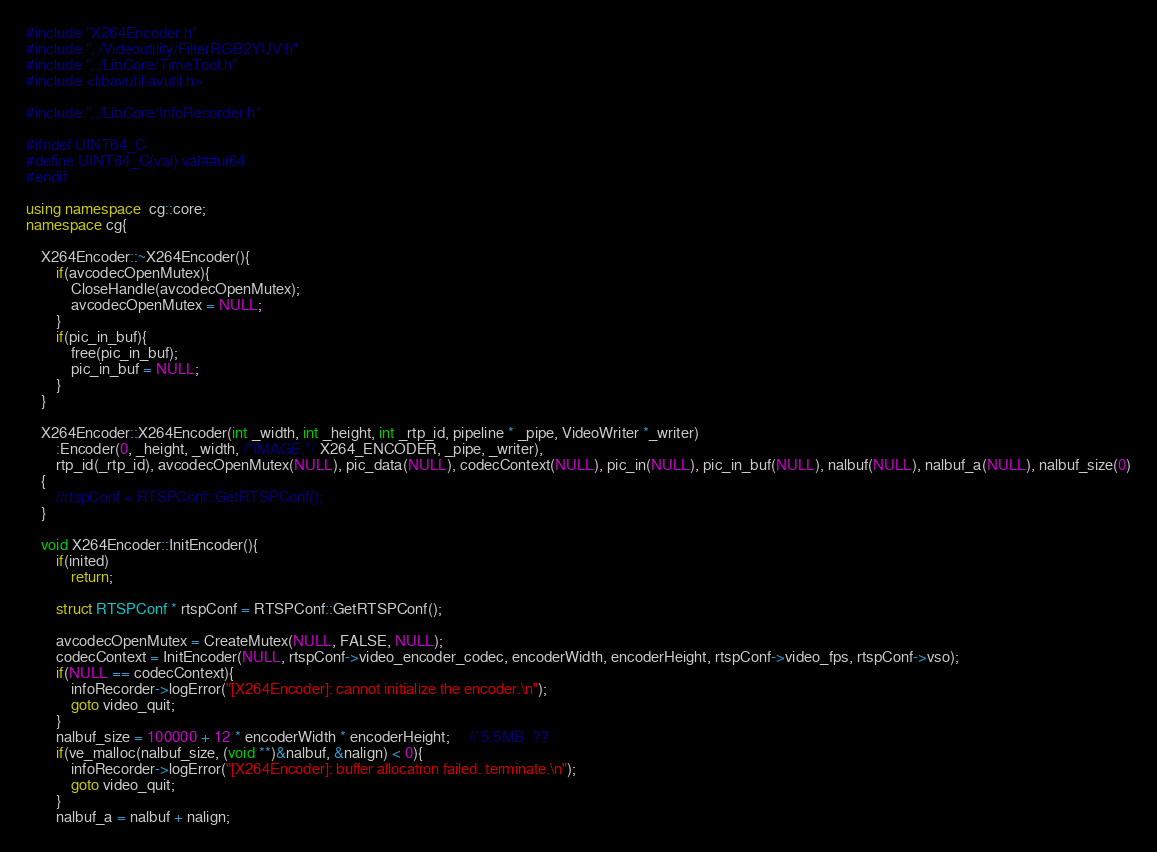Convert code to text. <code><loc_0><loc_0><loc_500><loc_500><_C++_>#include "X264Encoder.h"
#include "../Videoutility/FilterRGB2YUV.h"
#include "../LibCore/TimeTool.h"
#include <libavutil\avutil.h>

#include "../LibCore/InfoRecorder.h"

#ifndef UINT64_C
#define UINT64_C(val) val##ui64
#endif

using namespace  cg::core;
namespace cg{

	X264Encoder::~X264Encoder(){
		if(avcodecOpenMutex){
			CloseHandle(avcodecOpenMutex);
			avcodecOpenMutex = NULL;
		}
		if(pic_in_buf){
			free(pic_in_buf);
			pic_in_buf = NULL;
		}
	}

	X264Encoder::X264Encoder(int _width, int _height, int _rtp_id, pipeline * _pipe, VideoWriter *_writer)
		:Encoder(0, _height, _width, /*IMAGE,*/ X264_ENCODER, _pipe, _writer), 
		rtp_id(_rtp_id), avcodecOpenMutex(NULL), pic_data(NULL), codecContext(NULL), pic_in(NULL), pic_in_buf(NULL), nalbuf(NULL), nalbuf_a(NULL), nalbuf_size(0)
	{
		//rtspConf = RTSPConf::GetRTSPConf();
	}

	void X264Encoder::InitEncoder(){
		if(inited)
			return;

		struct RTSPConf * rtspConf = RTSPConf::GetRTSPConf();

		avcodecOpenMutex = CreateMutex(NULL, FALSE, NULL);
		codecContext = InitEncoder(NULL, rtspConf->video_encoder_codec, encoderWidth, encoderHeight, rtspConf->video_fps, rtspConf->vso);
		if(NULL == codecContext){
			infoRecorder->logError("[X264Encoder]: cannot initialize the encoder.\n");
			goto video_quit;
		}
		nalbuf_size = 100000 + 12 * encoderWidth * encoderHeight;     // 5.5MB  ??
		if(ve_malloc(nalbuf_size, (void **)&nalbuf, &nalign) < 0){
			infoRecorder->logError("[X264Encoder]: buffer allocation failed. terminate.\n");
			goto video_quit;
		}
		nalbuf_a = nalbuf + nalign;
</code> 